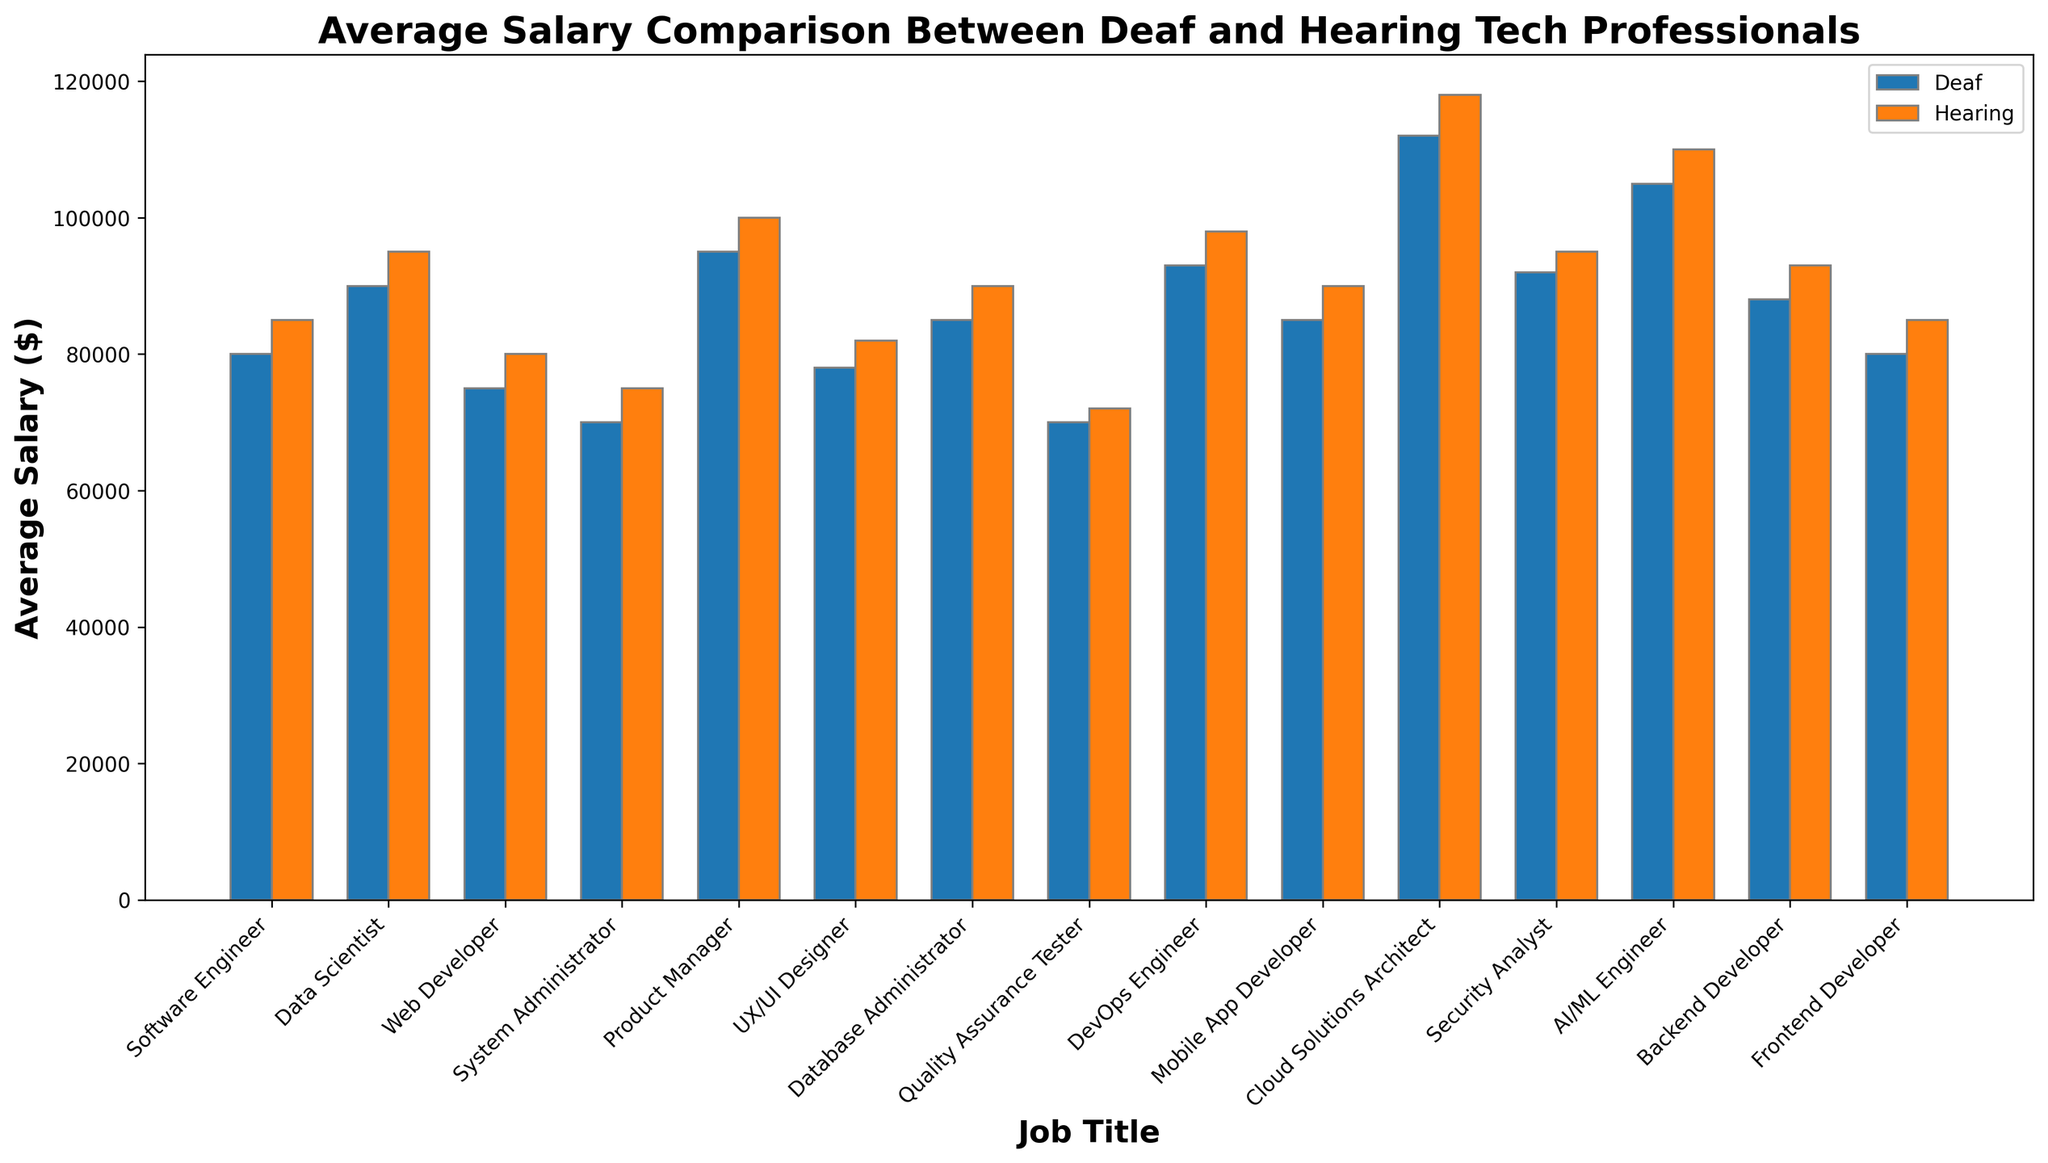What is the job title with the highest average salary difference between Deaf and Hearing tech professionals? To find the job title with the highest salary difference, we need to calculate the absolute difference for each job title and identify the maximum value. For instance, for Cloud Solutions Architect, the difference is 118000 - 112000 = 6000. Performing this calculation for all titles, we find that the largest difference is for Cloud Solutions Architect (6000).
Answer: Cloud Solutions Architect Which job titles have equal average salaries for both Deaf and Hearing tech professionals? Compare the average salaries for Deaf and Hearing professionals for each job title. No job titles have equal salaries in the data provided.
Answer: None Which job title shows the smallest salary gap between Deaf and Hearing tech professionals? Calculate the absolute salary differences for all job titles. For Quality Assurance Tester, the difference is the smallest at 72000 - 70000 = 2000. Hence, this job title shows the smallest salary gap.
Answer: Quality Assurance Tester Among Software Engineers and Data Scientists, which group (Deaf or Hearing) has a higher average salary? For Software Engineers, Hearing professionals earn 85000 vs Deaf at 80000. For Data Scientists, Hearing professionals earn 95000 vs Deaf at 90000. Therefore, Hearing professionals have higher average salaries in both job titles.
Answer: Hearing Which job title for Deaf tech professionals has the highest average salary? Review the average salaries for Deaf professionals and identify the highest. The highest value is for Cloud Solutions Architect at 112000.
Answer: Cloud Solutions Architect By how much is the average salary of Deaf DevOps Engineers lower than Hearing DevOps Engineers? Subtract the average salary of Deaf DevOps Engineers from Hearing DevOps Engineers: 98000 - 93000 = 5000.
Answer: 5000 What is the average salary of a Deaf tech professional working as an AI/ML Engineer compared to a Hearing one? The average salary for a Deaf AI/ML Engineer is 105000, while for a Hearing one's it is 110000. Therefore, a Deaf professional earns 5000 less on average.
Answer: 5000 less Which job title has the same average salary difference between Deaf and Hearing professionals as Backend Developer? First, calculate the difference for Backend Developer (93000 - 88000 = 5000). Next, compare this to other job titles: Software Engineer (5000), Data Scientist (5000), and Mobile App Developer (5000) have the same difference.
Answer: Software Engineer, Data Scientist, Mobile App Developer How much more, on average, does a Hearing Product Manager make compared to a Deaf UX/UI Designer? Calculate the difference: 100000 (Hearing Product Manager) - 78000 (Deaf UX/UI Designer) = 22000.
Answer: 22000 What is the total sum of the average salaries for both Deaf and Hearing tech professionals in the System Administrator role? Add the average salaries of Deaf and Hearing System Administrators: 70000 + 75000 = 145000.
Answer: 145000 